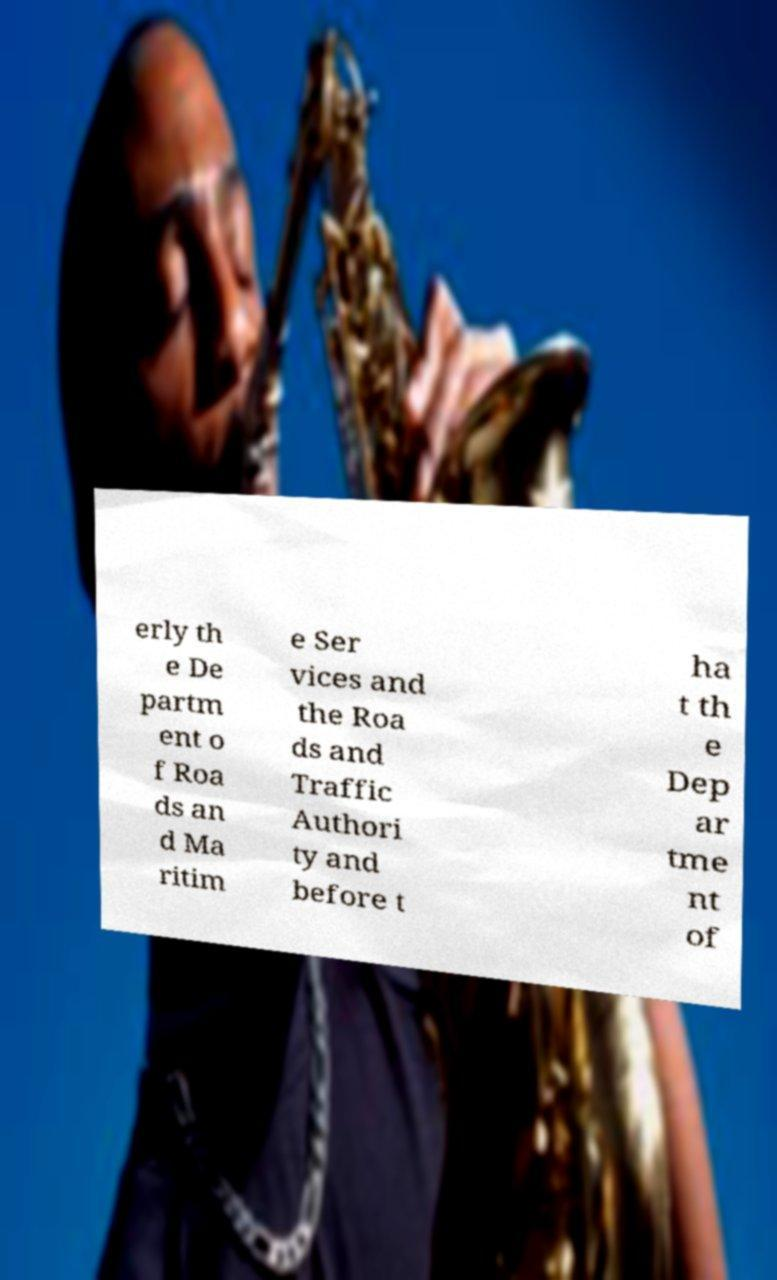For documentation purposes, I need the text within this image transcribed. Could you provide that? erly th e De partm ent o f Roa ds an d Ma ritim e Ser vices and the Roa ds and Traffic Authori ty and before t ha t th e Dep ar tme nt of 